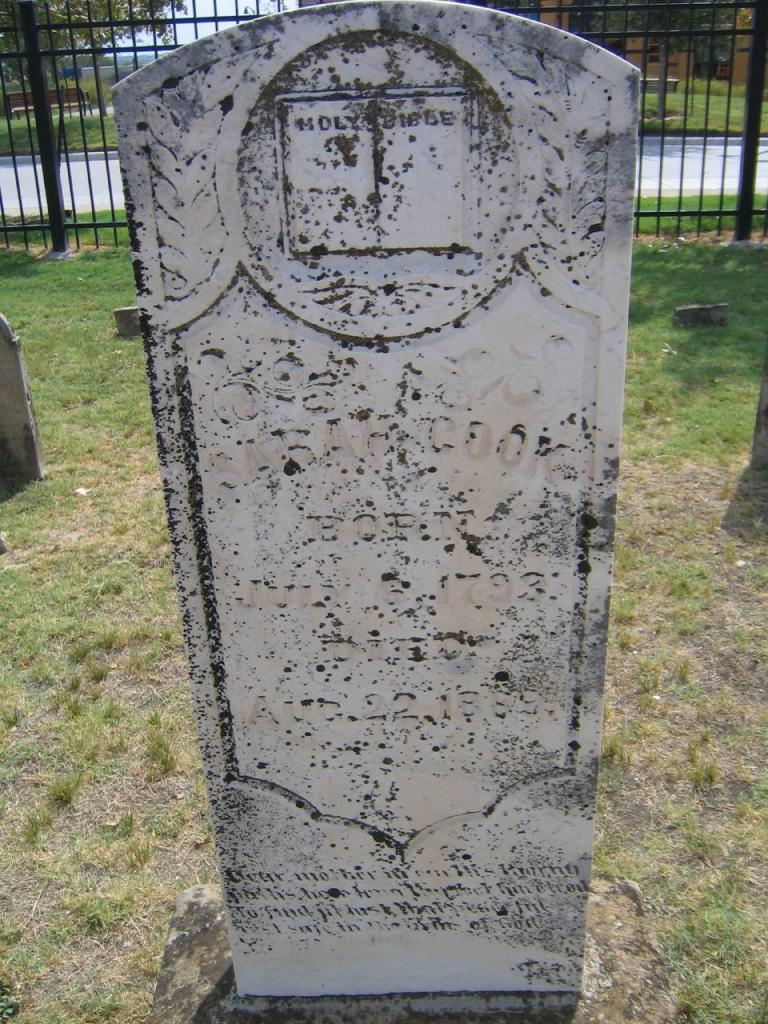What is the main subject of the image? There is a grave in the image. What is located near the grave? There is a stone near the grave. What type of vegetation is present in the image? Grass is present on the ground. What type of barrier is visible in the image? There is a metal fence in the image. What else can be seen in the background of the image? Trees are visible in the image. What type of soap is being used to clean the grave in the image? There is no soap present in the image, and the grave does not appear to be being cleaned. 